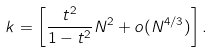<formula> <loc_0><loc_0><loc_500><loc_500>k = \left [ \frac { t ^ { 2 } } { 1 - t ^ { 2 } } N ^ { 2 } + o ( N ^ { 4 / 3 } ) \right ] .</formula> 